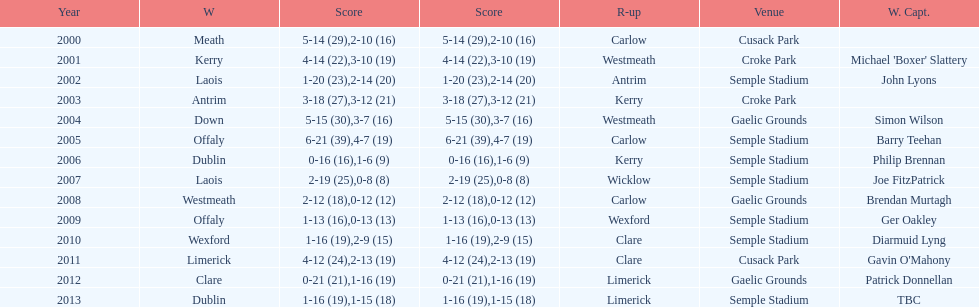How do the scores from 2000 vary? 13. 